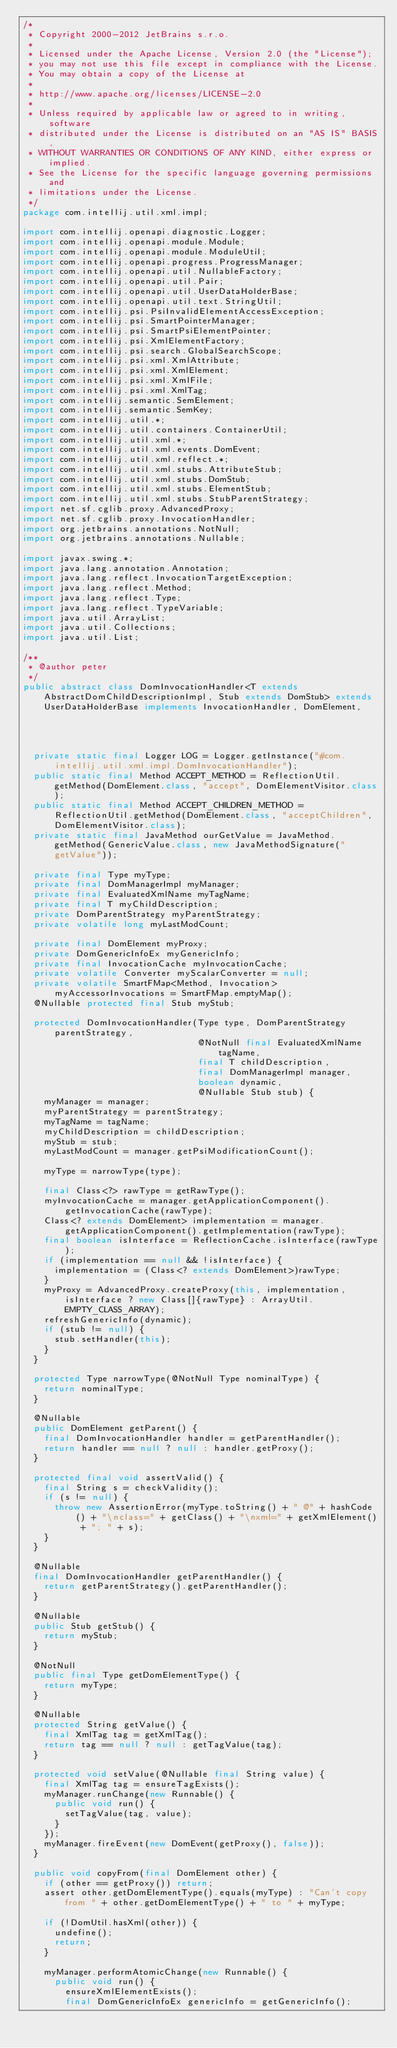<code> <loc_0><loc_0><loc_500><loc_500><_Java_>/*
 * Copyright 2000-2012 JetBrains s.r.o.
 *
 * Licensed under the Apache License, Version 2.0 (the "License");
 * you may not use this file except in compliance with the License.
 * You may obtain a copy of the License at
 *
 * http://www.apache.org/licenses/LICENSE-2.0
 *
 * Unless required by applicable law or agreed to in writing, software
 * distributed under the License is distributed on an "AS IS" BASIS,
 * WITHOUT WARRANTIES OR CONDITIONS OF ANY KIND, either express or implied.
 * See the License for the specific language governing permissions and
 * limitations under the License.
 */
package com.intellij.util.xml.impl;

import com.intellij.openapi.diagnostic.Logger;
import com.intellij.openapi.module.Module;
import com.intellij.openapi.module.ModuleUtil;
import com.intellij.openapi.progress.ProgressManager;
import com.intellij.openapi.util.NullableFactory;
import com.intellij.openapi.util.Pair;
import com.intellij.openapi.util.UserDataHolderBase;
import com.intellij.openapi.util.text.StringUtil;
import com.intellij.psi.PsiInvalidElementAccessException;
import com.intellij.psi.SmartPointerManager;
import com.intellij.psi.SmartPsiElementPointer;
import com.intellij.psi.XmlElementFactory;
import com.intellij.psi.search.GlobalSearchScope;
import com.intellij.psi.xml.XmlAttribute;
import com.intellij.psi.xml.XmlElement;
import com.intellij.psi.xml.XmlFile;
import com.intellij.psi.xml.XmlTag;
import com.intellij.semantic.SemElement;
import com.intellij.semantic.SemKey;
import com.intellij.util.*;
import com.intellij.util.containers.ContainerUtil;
import com.intellij.util.xml.*;
import com.intellij.util.xml.events.DomEvent;
import com.intellij.util.xml.reflect.*;
import com.intellij.util.xml.stubs.AttributeStub;
import com.intellij.util.xml.stubs.DomStub;
import com.intellij.util.xml.stubs.ElementStub;
import com.intellij.util.xml.stubs.StubParentStrategy;
import net.sf.cglib.proxy.AdvancedProxy;
import net.sf.cglib.proxy.InvocationHandler;
import org.jetbrains.annotations.NotNull;
import org.jetbrains.annotations.Nullable;

import javax.swing.*;
import java.lang.annotation.Annotation;
import java.lang.reflect.InvocationTargetException;
import java.lang.reflect.Method;
import java.lang.reflect.Type;
import java.lang.reflect.TypeVariable;
import java.util.ArrayList;
import java.util.Collections;
import java.util.List;

/**
 * @author peter
 */
public abstract class DomInvocationHandler<T extends AbstractDomChildDescriptionImpl, Stub extends DomStub> extends UserDataHolderBase implements InvocationHandler, DomElement,
                                                                                                                            SemElement {
  private static final Logger LOG = Logger.getInstance("#com.intellij.util.xml.impl.DomInvocationHandler");
  public static final Method ACCEPT_METHOD = ReflectionUtil.getMethod(DomElement.class, "accept", DomElementVisitor.class);
  public static final Method ACCEPT_CHILDREN_METHOD = ReflectionUtil.getMethod(DomElement.class, "acceptChildren", DomElementVisitor.class);
  private static final JavaMethod ourGetValue = JavaMethod.getMethod(GenericValue.class, new JavaMethodSignature("getValue"));

  private final Type myType;
  private final DomManagerImpl myManager;
  private final EvaluatedXmlName myTagName;
  private final T myChildDescription;
  private DomParentStrategy myParentStrategy;
  private volatile long myLastModCount;

  private final DomElement myProxy;
  private DomGenericInfoEx myGenericInfo;
  private final InvocationCache myInvocationCache;
  private volatile Converter myScalarConverter = null;
  private volatile SmartFMap<Method, Invocation> myAccessorInvocations = SmartFMap.emptyMap();
  @Nullable protected final Stub myStub;

  protected DomInvocationHandler(Type type, DomParentStrategy parentStrategy,
                                 @NotNull final EvaluatedXmlName tagName,
                                 final T childDescription,
                                 final DomManagerImpl manager,
                                 boolean dynamic,
                                 @Nullable Stub stub) {
    myManager = manager;
    myParentStrategy = parentStrategy;
    myTagName = tagName;
    myChildDescription = childDescription;
    myStub = stub;
    myLastModCount = manager.getPsiModificationCount();

    myType = narrowType(type);

    final Class<?> rawType = getRawType();
    myInvocationCache = manager.getApplicationComponent().getInvocationCache(rawType);
    Class<? extends DomElement> implementation = manager.getApplicationComponent().getImplementation(rawType);
    final boolean isInterface = ReflectionCache.isInterface(rawType);
    if (implementation == null && !isInterface) {
      implementation = (Class<? extends DomElement>)rawType;
    }
    myProxy = AdvancedProxy.createProxy(this, implementation, isInterface ? new Class[]{rawType} : ArrayUtil.EMPTY_CLASS_ARRAY);
    refreshGenericInfo(dynamic);
    if (stub != null) {
      stub.setHandler(this);
    }
  }

  protected Type narrowType(@NotNull Type nominalType) {
    return nominalType;
  }

  @Nullable
  public DomElement getParent() {
    final DomInvocationHandler handler = getParentHandler();
    return handler == null ? null : handler.getProxy();
  }

  protected final void assertValid() {
    final String s = checkValidity();
    if (s != null) {
      throw new AssertionError(myType.toString() + " @" + hashCode() + "\nclass=" + getClass() + "\nxml=" + getXmlElement() + "; " + s);
    }
  }

  @Nullable
  final DomInvocationHandler getParentHandler() {
    return getParentStrategy().getParentHandler();
  }

  @Nullable
  public Stub getStub() {
    return myStub;
  }

  @NotNull
  public final Type getDomElementType() {
    return myType;
  }

  @Nullable
  protected String getValue() {
    final XmlTag tag = getXmlTag();
    return tag == null ? null : getTagValue(tag);
  }

  protected void setValue(@Nullable final String value) {
    final XmlTag tag = ensureTagExists();
    myManager.runChange(new Runnable() {
      public void run() {
        setTagValue(tag, value);
      }
    });
    myManager.fireEvent(new DomEvent(getProxy(), false));
  }

  public void copyFrom(final DomElement other) {
    if (other == getProxy()) return;
    assert other.getDomElementType().equals(myType) : "Can't copy from " + other.getDomElementType() + " to " + myType;

    if (!DomUtil.hasXml(other)) {
      undefine();
      return;
    }

    myManager.performAtomicChange(new Runnable() {
      public void run() {
        ensureXmlElementExists();
        final DomGenericInfoEx genericInfo = getGenericInfo();</code> 